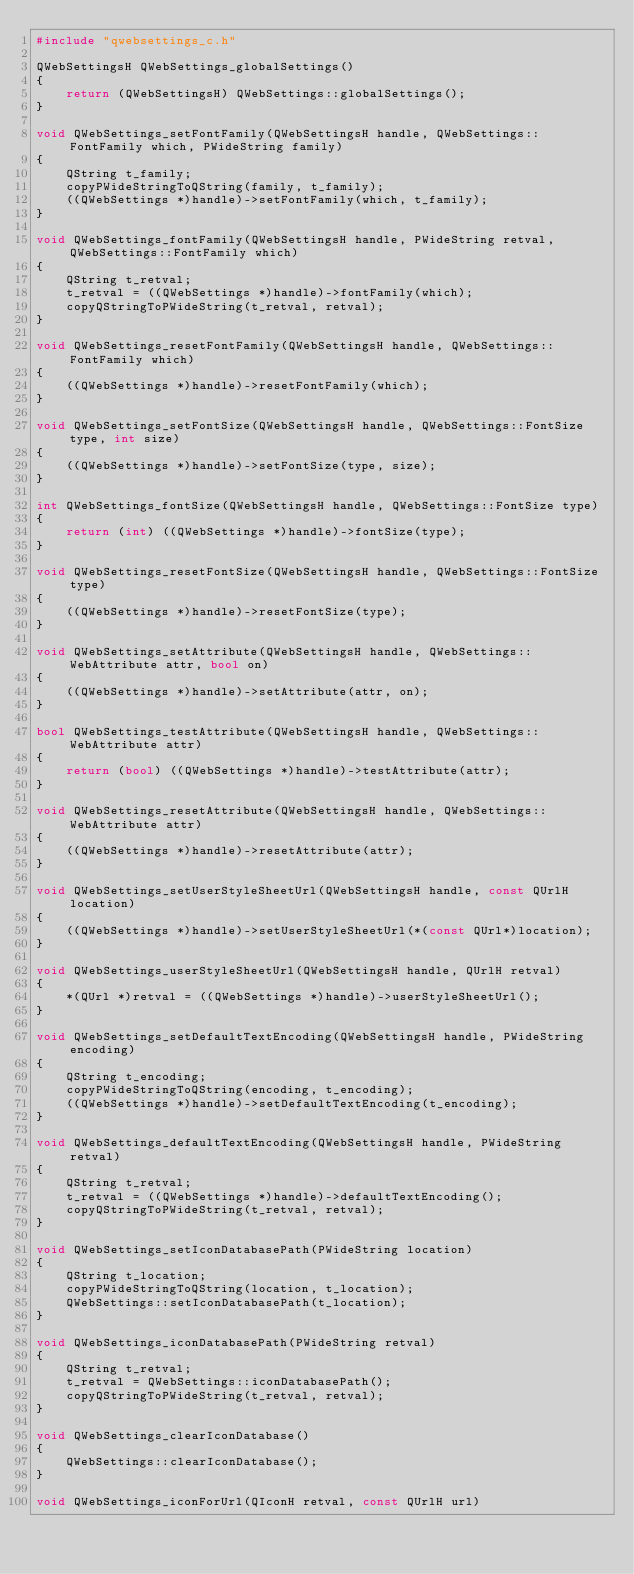Convert code to text. <code><loc_0><loc_0><loc_500><loc_500><_C++_>#include "qwebsettings_c.h"

QWebSettingsH QWebSettings_globalSettings()
{
	return (QWebSettingsH) QWebSettings::globalSettings();
}

void QWebSettings_setFontFamily(QWebSettingsH handle, QWebSettings::FontFamily which, PWideString family)
{
	QString t_family;
	copyPWideStringToQString(family, t_family);
	((QWebSettings *)handle)->setFontFamily(which, t_family);
}

void QWebSettings_fontFamily(QWebSettingsH handle, PWideString retval, QWebSettings::FontFamily which)
{
	QString t_retval;
	t_retval = ((QWebSettings *)handle)->fontFamily(which);
	copyQStringToPWideString(t_retval, retval);
}

void QWebSettings_resetFontFamily(QWebSettingsH handle, QWebSettings::FontFamily which)
{
	((QWebSettings *)handle)->resetFontFamily(which);
}

void QWebSettings_setFontSize(QWebSettingsH handle, QWebSettings::FontSize type, int size)
{
	((QWebSettings *)handle)->setFontSize(type, size);
}

int QWebSettings_fontSize(QWebSettingsH handle, QWebSettings::FontSize type)
{
	return (int) ((QWebSettings *)handle)->fontSize(type);
}

void QWebSettings_resetFontSize(QWebSettingsH handle, QWebSettings::FontSize type)
{
	((QWebSettings *)handle)->resetFontSize(type);
}

void QWebSettings_setAttribute(QWebSettingsH handle, QWebSettings::WebAttribute attr, bool on)
{
	((QWebSettings *)handle)->setAttribute(attr, on);
}

bool QWebSettings_testAttribute(QWebSettingsH handle, QWebSettings::WebAttribute attr)
{
	return (bool) ((QWebSettings *)handle)->testAttribute(attr);
}

void QWebSettings_resetAttribute(QWebSettingsH handle, QWebSettings::WebAttribute attr)
{
	((QWebSettings *)handle)->resetAttribute(attr);
}

void QWebSettings_setUserStyleSheetUrl(QWebSettingsH handle, const QUrlH location)
{
	((QWebSettings *)handle)->setUserStyleSheetUrl(*(const QUrl*)location);
}

void QWebSettings_userStyleSheetUrl(QWebSettingsH handle, QUrlH retval)
{
	*(QUrl *)retval = ((QWebSettings *)handle)->userStyleSheetUrl();
}

void QWebSettings_setDefaultTextEncoding(QWebSettingsH handle, PWideString encoding)
{
	QString t_encoding;
	copyPWideStringToQString(encoding, t_encoding);
	((QWebSettings *)handle)->setDefaultTextEncoding(t_encoding);
}

void QWebSettings_defaultTextEncoding(QWebSettingsH handle, PWideString retval)
{
	QString t_retval;
	t_retval = ((QWebSettings *)handle)->defaultTextEncoding();
	copyQStringToPWideString(t_retval, retval);
}

void QWebSettings_setIconDatabasePath(PWideString location)
{
	QString t_location;
	copyPWideStringToQString(location, t_location);
	QWebSettings::setIconDatabasePath(t_location);
}

void QWebSettings_iconDatabasePath(PWideString retval)
{
	QString t_retval;
	t_retval = QWebSettings::iconDatabasePath();
	copyQStringToPWideString(t_retval, retval);
}

void QWebSettings_clearIconDatabase()
{
	QWebSettings::clearIconDatabase();
}

void QWebSettings_iconForUrl(QIconH retval, const QUrlH url)</code> 